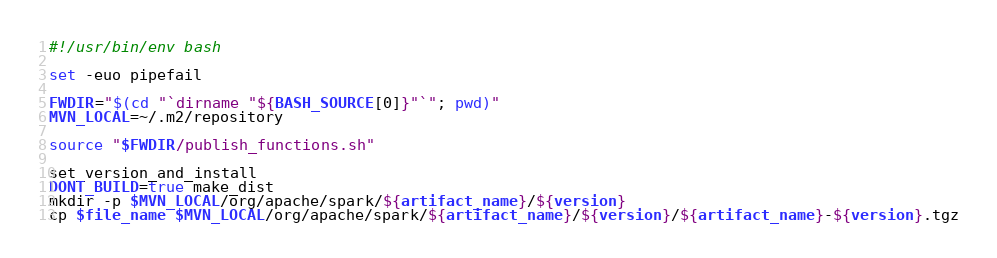<code> <loc_0><loc_0><loc_500><loc_500><_Bash_>#!/usr/bin/env bash

set -euo pipefail

FWDIR="$(cd "`dirname "${BASH_SOURCE[0]}"`"; pwd)"
MVN_LOCAL=~/.m2/repository

source "$FWDIR/publish_functions.sh"

set_version_and_install
DONT_BUILD=true make_dist
mkdir -p $MVN_LOCAL/org/apache/spark/${artifact_name}/${version}
cp $file_name $MVN_LOCAL/org/apache/spark/${artifact_name}/${version}/${artifact_name}-${version}.tgz
</code> 